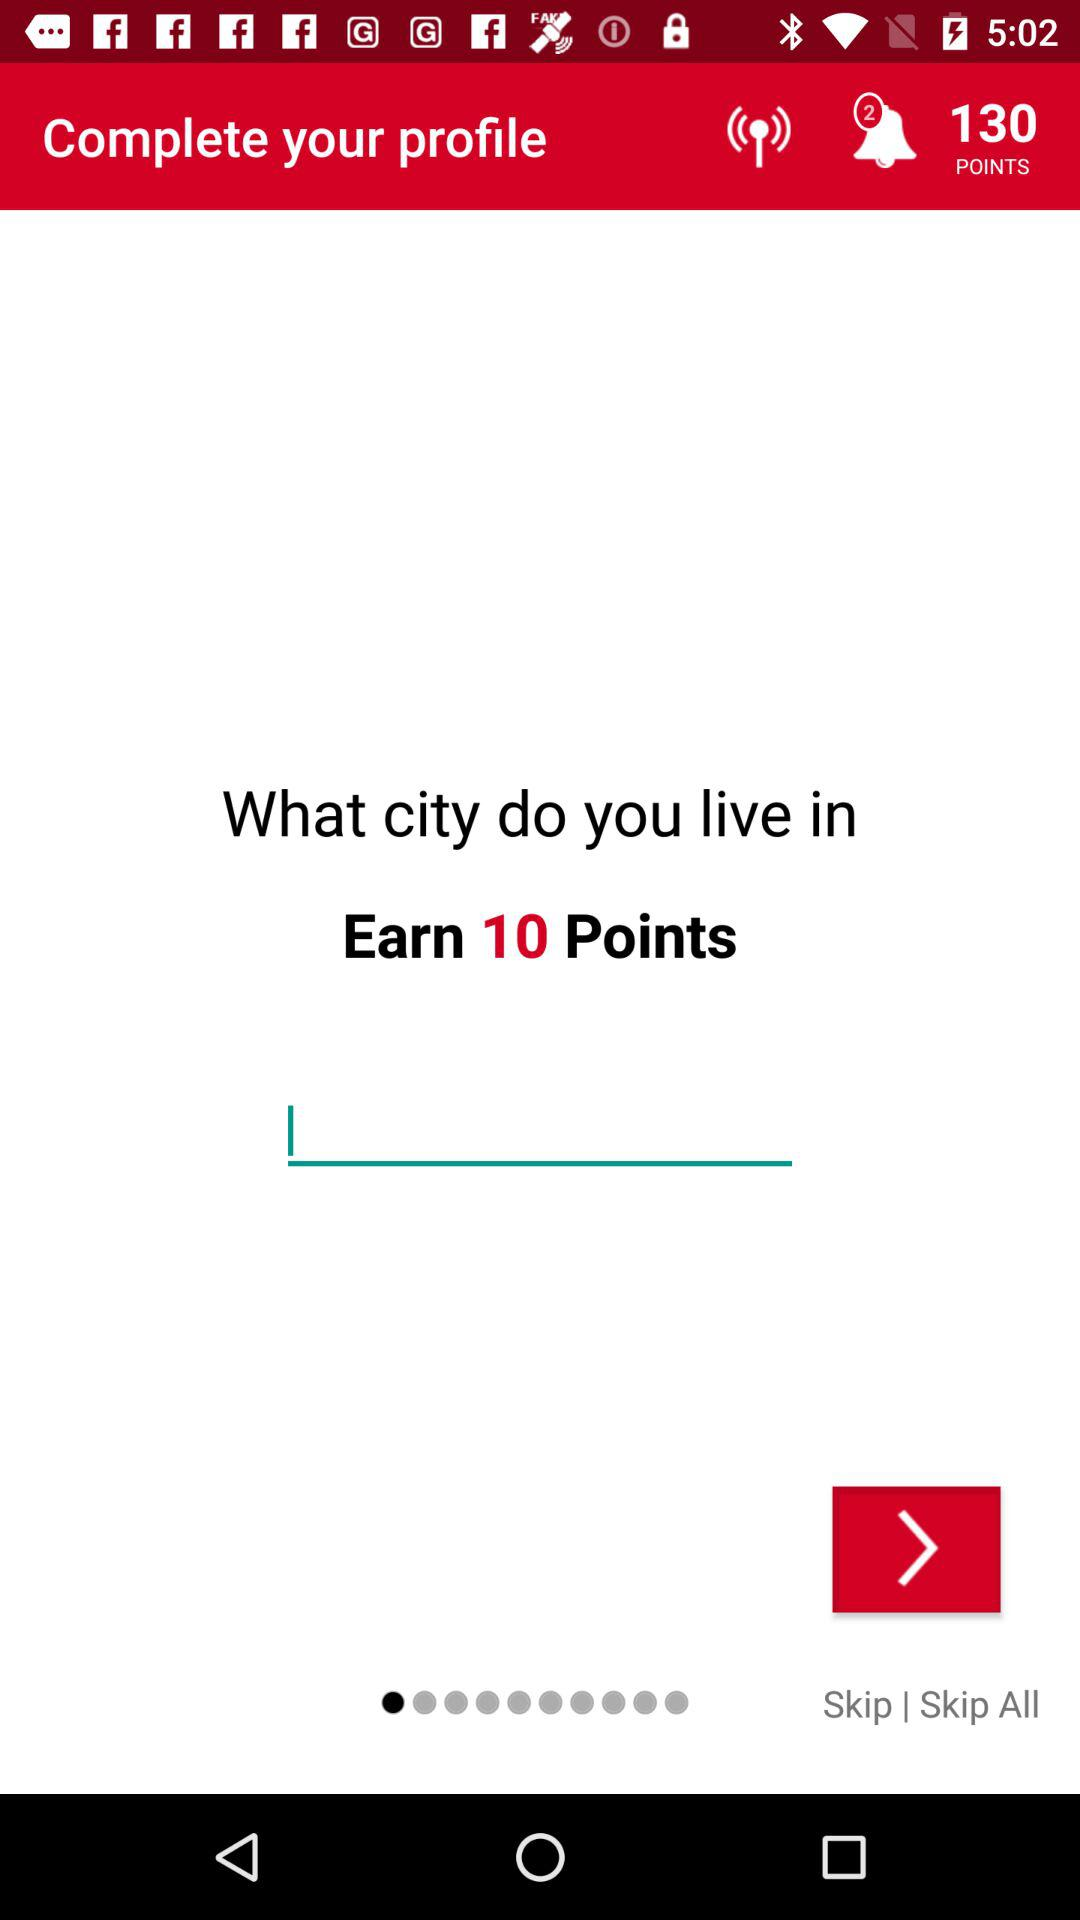How many points are available for completing my profile?
Answer the question using a single word or phrase. 10 